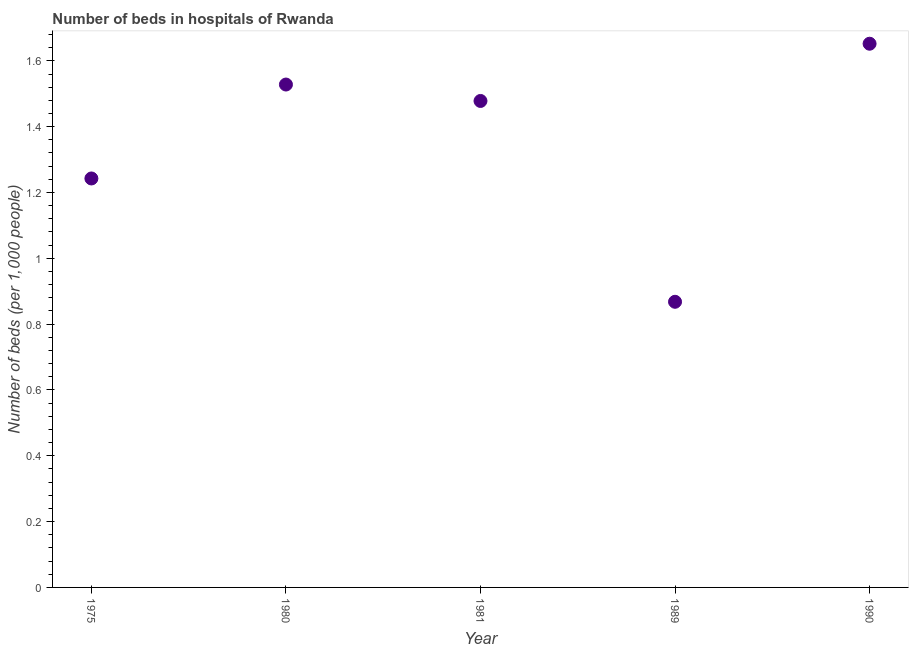What is the number of hospital beds in 1989?
Offer a very short reply. 0.87. Across all years, what is the maximum number of hospital beds?
Offer a very short reply. 1.65. Across all years, what is the minimum number of hospital beds?
Your answer should be very brief. 0.87. In which year was the number of hospital beds maximum?
Give a very brief answer. 1990. In which year was the number of hospital beds minimum?
Your response must be concise. 1989. What is the sum of the number of hospital beds?
Ensure brevity in your answer.  6.77. What is the difference between the number of hospital beds in 1981 and 1990?
Provide a short and direct response. -0.17. What is the average number of hospital beds per year?
Provide a succinct answer. 1.35. What is the median number of hospital beds?
Offer a terse response. 1.48. Do a majority of the years between 1975 and 1990 (inclusive) have number of hospital beds greater than 1.2800000000000002 %?
Ensure brevity in your answer.  Yes. What is the ratio of the number of hospital beds in 1989 to that in 1990?
Your response must be concise. 0.53. Is the number of hospital beds in 1989 less than that in 1990?
Offer a terse response. Yes. Is the difference between the number of hospital beds in 1975 and 1990 greater than the difference between any two years?
Provide a short and direct response. No. What is the difference between the highest and the second highest number of hospital beds?
Your answer should be very brief. 0.12. What is the difference between the highest and the lowest number of hospital beds?
Your answer should be compact. 0.78. Does the number of hospital beds monotonically increase over the years?
Give a very brief answer. No. What is the difference between two consecutive major ticks on the Y-axis?
Make the answer very short. 0.2. Does the graph contain any zero values?
Offer a terse response. No. Does the graph contain grids?
Your answer should be very brief. No. What is the title of the graph?
Offer a very short reply. Number of beds in hospitals of Rwanda. What is the label or title of the Y-axis?
Your response must be concise. Number of beds (per 1,0 people). What is the Number of beds (per 1,000 people) in 1975?
Offer a terse response. 1.24. What is the Number of beds (per 1,000 people) in 1980?
Provide a short and direct response. 1.53. What is the Number of beds (per 1,000 people) in 1981?
Make the answer very short. 1.48. What is the Number of beds (per 1,000 people) in 1989?
Make the answer very short. 0.87. What is the Number of beds (per 1,000 people) in 1990?
Your response must be concise. 1.65. What is the difference between the Number of beds (per 1,000 people) in 1975 and 1980?
Ensure brevity in your answer.  -0.29. What is the difference between the Number of beds (per 1,000 people) in 1975 and 1981?
Offer a terse response. -0.24. What is the difference between the Number of beds (per 1,000 people) in 1975 and 1989?
Offer a very short reply. 0.37. What is the difference between the Number of beds (per 1,000 people) in 1975 and 1990?
Offer a very short reply. -0.41. What is the difference between the Number of beds (per 1,000 people) in 1980 and 1981?
Offer a very short reply. 0.05. What is the difference between the Number of beds (per 1,000 people) in 1980 and 1989?
Your response must be concise. 0.66. What is the difference between the Number of beds (per 1,000 people) in 1980 and 1990?
Offer a terse response. -0.12. What is the difference between the Number of beds (per 1,000 people) in 1981 and 1989?
Provide a short and direct response. 0.61. What is the difference between the Number of beds (per 1,000 people) in 1981 and 1990?
Make the answer very short. -0.17. What is the difference between the Number of beds (per 1,000 people) in 1989 and 1990?
Provide a succinct answer. -0.78. What is the ratio of the Number of beds (per 1,000 people) in 1975 to that in 1980?
Give a very brief answer. 0.81. What is the ratio of the Number of beds (per 1,000 people) in 1975 to that in 1981?
Provide a succinct answer. 0.84. What is the ratio of the Number of beds (per 1,000 people) in 1975 to that in 1989?
Give a very brief answer. 1.43. What is the ratio of the Number of beds (per 1,000 people) in 1975 to that in 1990?
Provide a succinct answer. 0.75. What is the ratio of the Number of beds (per 1,000 people) in 1980 to that in 1981?
Provide a short and direct response. 1.03. What is the ratio of the Number of beds (per 1,000 people) in 1980 to that in 1989?
Offer a terse response. 1.76. What is the ratio of the Number of beds (per 1,000 people) in 1980 to that in 1990?
Offer a terse response. 0.93. What is the ratio of the Number of beds (per 1,000 people) in 1981 to that in 1989?
Provide a short and direct response. 1.7. What is the ratio of the Number of beds (per 1,000 people) in 1981 to that in 1990?
Your response must be concise. 0.9. What is the ratio of the Number of beds (per 1,000 people) in 1989 to that in 1990?
Provide a succinct answer. 0.53. 